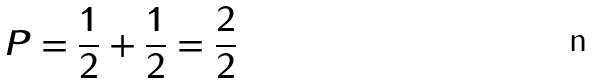Convert formula to latex. <formula><loc_0><loc_0><loc_500><loc_500>P = \frac { 1 } { 2 } + \frac { 1 } { 2 } = \frac { 2 } { 2 }</formula> 